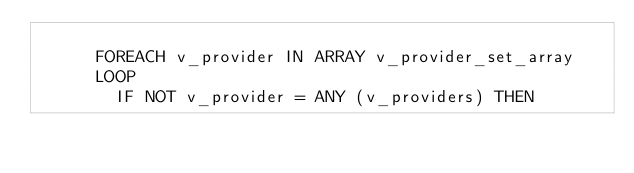<code> <loc_0><loc_0><loc_500><loc_500><_SQL_>      
      FOREACH v_provider IN ARRAY v_provider_set_array
      LOOP
        IF NOT v_provider = ANY (v_providers) THEN</code> 